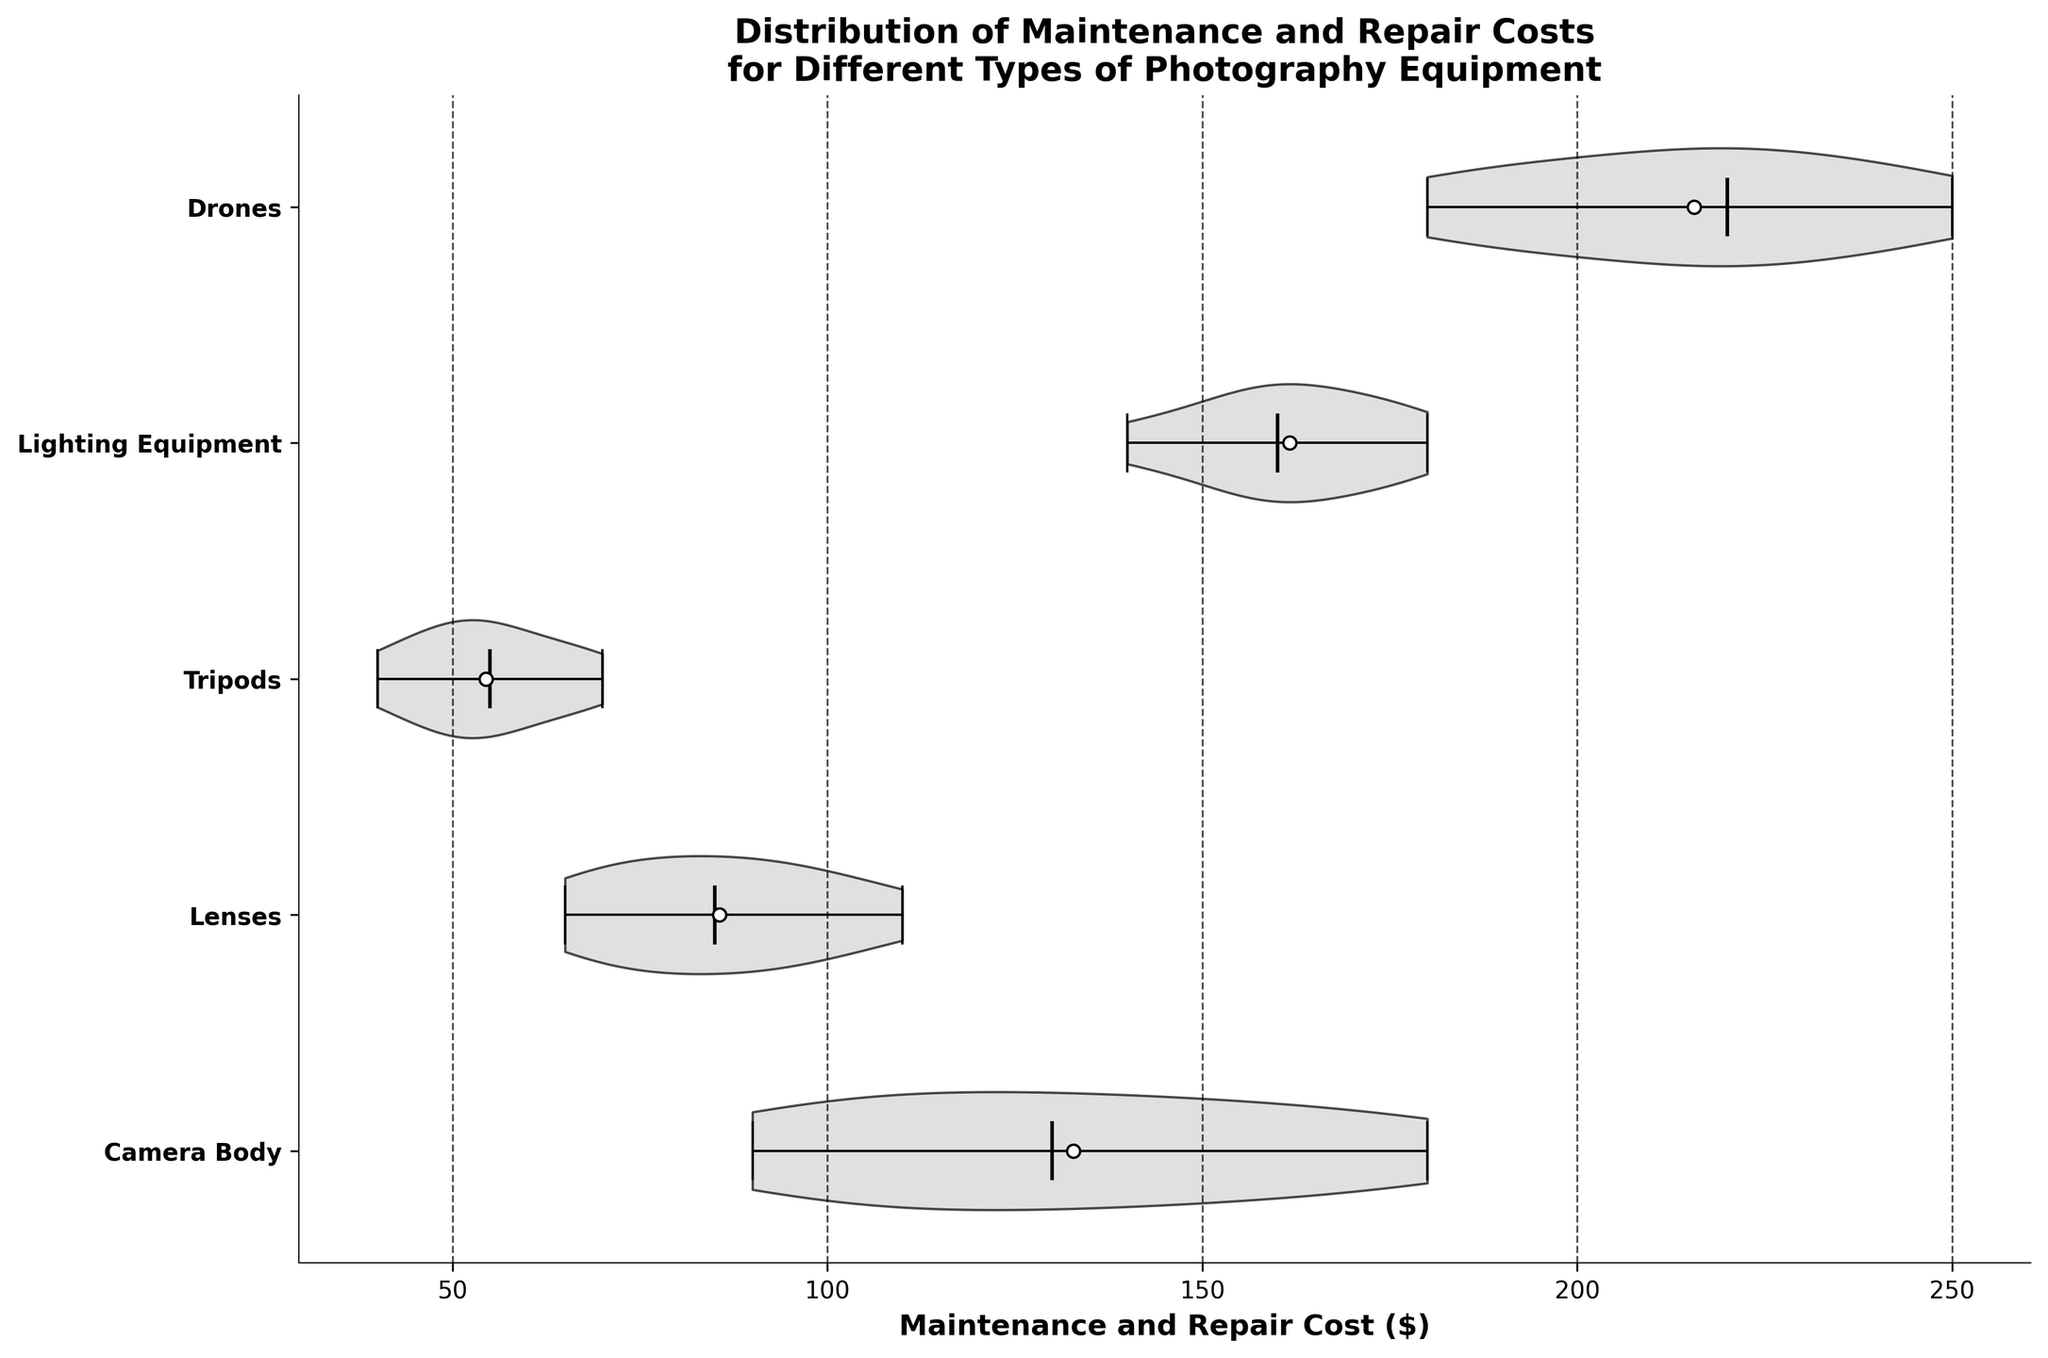What is the title of the plot? The title of the plot is mentioned at the top of the figure and provides context about what the plot is displaying. Referencing the figure, the title reads "Distribution of Maintenance and Repair Costs for Different Types of Photography Equipment".
Answer: Distribution of Maintenance and Repair Costs for Different Types of Photography Equipment What does the x-axis represent? The x-axis of the plot is labeled, indicating that it represents the "Maintenance and Repair Cost ($)".
Answer: Maintenance and Repair Cost ($) What are the equipment types shown on the y-axis? The y-axis lists the different types of photography equipment, which are: Camera Body, Lenses, Tripods, Lighting Equipment, and Drones.
Answer: Camera Body, Lenses, Tripods, Lighting Equipment, Drones Which equipment type has the widest range of maintenance and repair costs? By observing the horizontal span of each violin plot, the one with the widest range is the Drones, as it spans from approximately $180 to $250.
Answer: Drones Which equipment type has the highest median maintenance and repair cost? The highest median line can be found by looking at the bold horizontal line within each violin plot. The Drones category has the highest median around $220.
Answer: Drones What is the approximate mean maintenance and repair cost for tripods? The mean is marked by a white dot within each violin plot. For tripods, the white dot is located roughly at $55.
Answer: $55 How does the repair cost distribution for Lenses compare to that of Lighting Equipment? By comparing the shapes of the violin plots for Lenses and Lighting Equipment, Lenses have a narrower distribution ranging from $65 to $110, whereas Lighting Equipment has a broader range approximately from $140 to $180. This suggests more variability in the maintenance and repair costs for Lighting Equipment compared to Lenses.
Answer: Lighting Equipment has a broader distribution and higher costs Between Canon and Sony brands, which one has higher maintenance and repair costs for camera bodies? Looking at the portions of the violin plots corresponding to Camera Body for both brands, Sony tends to have higher maintenance and repair costs, with its range being higher than Canon's.
Answer: Sony What is the approximate range of maintenance and repair costs for tripods? Looking at the horizontal spread of the violin plot for Tripods, it ranges approximately from $40 to $70.
Answer: $40 to $70 Which equipment type has the smallest variability in maintenance and repair costs? The equipment type with the narrowest violin plot indicates the smallest variability. This appears to be the Tripods, with values tightly clustered around the mean and median.
Answer: Tripods 